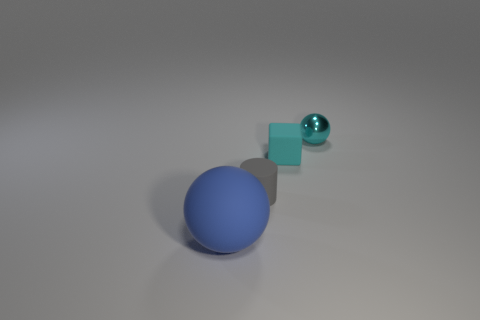Add 1 small green matte cylinders. How many objects exist? 5 Subtract all blocks. How many objects are left? 3 Add 4 tiny cyan balls. How many tiny cyan balls exist? 5 Subtract 1 cyan balls. How many objects are left? 3 Subtract all large cyan balls. Subtract all blue rubber objects. How many objects are left? 3 Add 4 balls. How many balls are left? 6 